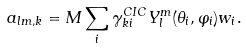Convert formula to latex. <formula><loc_0><loc_0><loc_500><loc_500>a _ { l m , k } = M \sum _ { i } \gamma _ { k i } ^ { C I C } Y _ { l } ^ { m } ( \theta _ { i } , \varphi _ { i } ) w _ { i } .</formula> 